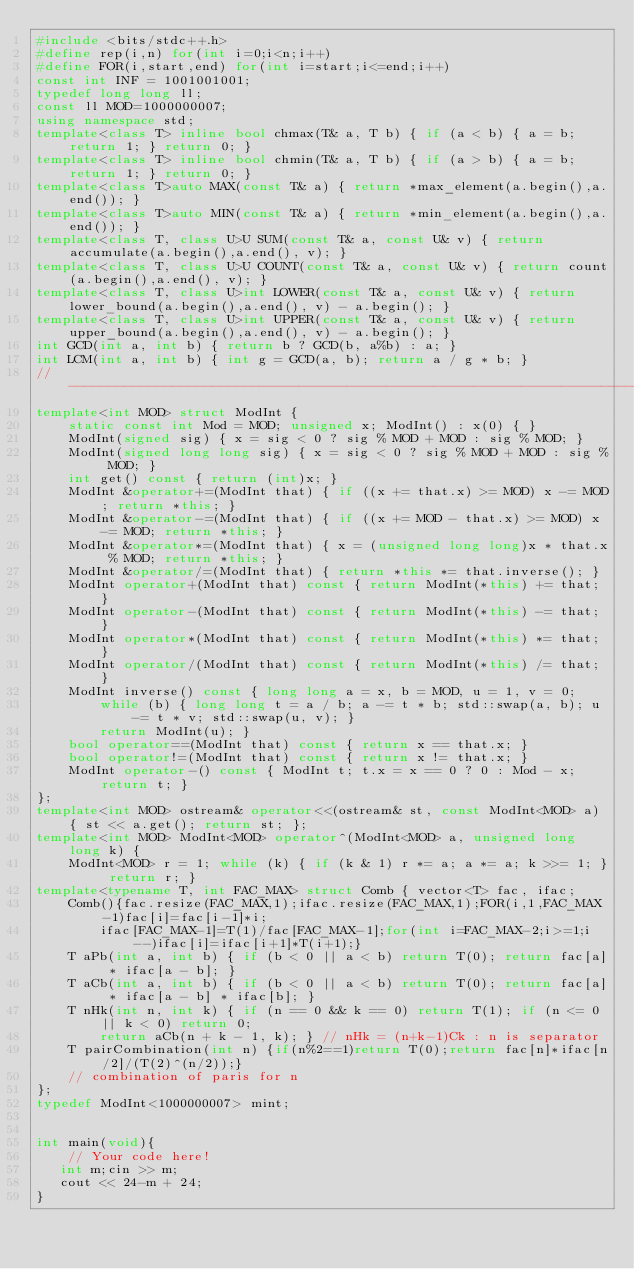<code> <loc_0><loc_0><loc_500><loc_500><_C++_>#include <bits/stdc++.h>
#define rep(i,n) for(int i=0;i<n;i++)
#define FOR(i,start,end) for(int i=start;i<=end;i++)
const int INF = 1001001001;
typedef long long ll;
const ll MOD=1000000007;
using namespace std;
template<class T> inline bool chmax(T& a, T b) { if (a < b) { a = b; return 1; } return 0; }
template<class T> inline bool chmin(T& a, T b) { if (a > b) { a = b; return 1; } return 0; }
template<class T>auto MAX(const T& a) { return *max_element(a.begin(),a.end()); }
template<class T>auto MIN(const T& a) { return *min_element(a.begin(),a.end()); }
template<class T, class U>U SUM(const T& a, const U& v) { return accumulate(a.begin(),a.end(), v); }
template<class T, class U>U COUNT(const T& a, const U& v) { return count(a.begin(),a.end(), v); }
template<class T, class U>int LOWER(const T& a, const U& v) { return lower_bound(a.begin(),a.end(), v) - a.begin(); }
template<class T, class U>int UPPER(const T& a, const U& v) { return upper_bound(a.begin(),a.end(), v) - a.begin(); }
int GCD(int a, int b) { return b ? GCD(b, a%b) : a; }
int LCM(int a, int b) { int g = GCD(a, b); return a / g * b; }
//---------------------------------------------------------------------------------------------------
template<int MOD> struct ModInt {
    static const int Mod = MOD; unsigned x; ModInt() : x(0) { }
    ModInt(signed sig) { x = sig < 0 ? sig % MOD + MOD : sig % MOD; }
    ModInt(signed long long sig) { x = sig < 0 ? sig % MOD + MOD : sig % MOD; }
    int get() const { return (int)x; }
    ModInt &operator+=(ModInt that) { if ((x += that.x) >= MOD) x -= MOD; return *this; }
    ModInt &operator-=(ModInt that) { if ((x += MOD - that.x) >= MOD) x -= MOD; return *this; }
    ModInt &operator*=(ModInt that) { x = (unsigned long long)x * that.x % MOD; return *this; }
    ModInt &operator/=(ModInt that) { return *this *= that.inverse(); }
    ModInt operator+(ModInt that) const { return ModInt(*this) += that; }
    ModInt operator-(ModInt that) const { return ModInt(*this) -= that; }
    ModInt operator*(ModInt that) const { return ModInt(*this) *= that; }
    ModInt operator/(ModInt that) const { return ModInt(*this) /= that; }
    ModInt inverse() const { long long a = x, b = MOD, u = 1, v = 0;
        while (b) { long long t = a / b; a -= t * b; std::swap(a, b); u -= t * v; std::swap(u, v); }
        return ModInt(u); }
    bool operator==(ModInt that) const { return x == that.x; }
    bool operator!=(ModInt that) const { return x != that.x; }
    ModInt operator-() const { ModInt t; t.x = x == 0 ? 0 : Mod - x; return t; }
};
template<int MOD> ostream& operator<<(ostream& st, const ModInt<MOD> a) { st << a.get(); return st; };
template<int MOD> ModInt<MOD> operator^(ModInt<MOD> a, unsigned long long k) {
    ModInt<MOD> r = 1; while (k) { if (k & 1) r *= a; a *= a; k >>= 1; } return r; }
template<typename T, int FAC_MAX> struct Comb { vector<T> fac, ifac;
    Comb(){fac.resize(FAC_MAX,1);ifac.resize(FAC_MAX,1);FOR(i,1,FAC_MAX-1)fac[i]=fac[i-1]*i;
        ifac[FAC_MAX-1]=T(1)/fac[FAC_MAX-1];for(int i=FAC_MAX-2;i>=1;i--)ifac[i]=ifac[i+1]*T(i+1);}
    T aPb(int a, int b) { if (b < 0 || a < b) return T(0); return fac[a] * ifac[a - b]; }
    T aCb(int a, int b) { if (b < 0 || a < b) return T(0); return fac[a] * ifac[a - b] * ifac[b]; }
    T nHk(int n, int k) { if (n == 0 && k == 0) return T(1); if (n <= 0 || k < 0) return 0;
        return aCb(n + k - 1, k); } // nHk = (n+k-1)Ck : n is separator
    T pairCombination(int n) {if(n%2==1)return T(0);return fac[n]*ifac[n/2]/(T(2)^(n/2));}
    // combination of paris for n
}; 
typedef ModInt<1000000007> mint;


int main(void){
    // Your code here!
   int m;cin >> m;
   cout << 24-m + 24; 
}
</code> 